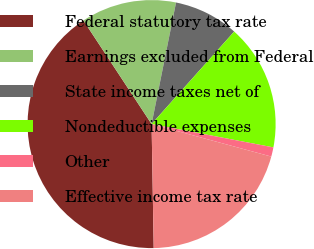<chart> <loc_0><loc_0><loc_500><loc_500><pie_chart><fcel>Federal statutory tax rate<fcel>Earnings excluded from Federal<fcel>State income taxes net of<fcel>Nondeductible expenses<fcel>Other<fcel>Effective income tax rate<nl><fcel>41.01%<fcel>12.42%<fcel>8.44%<fcel>16.41%<fcel>1.21%<fcel>20.51%<nl></chart> 